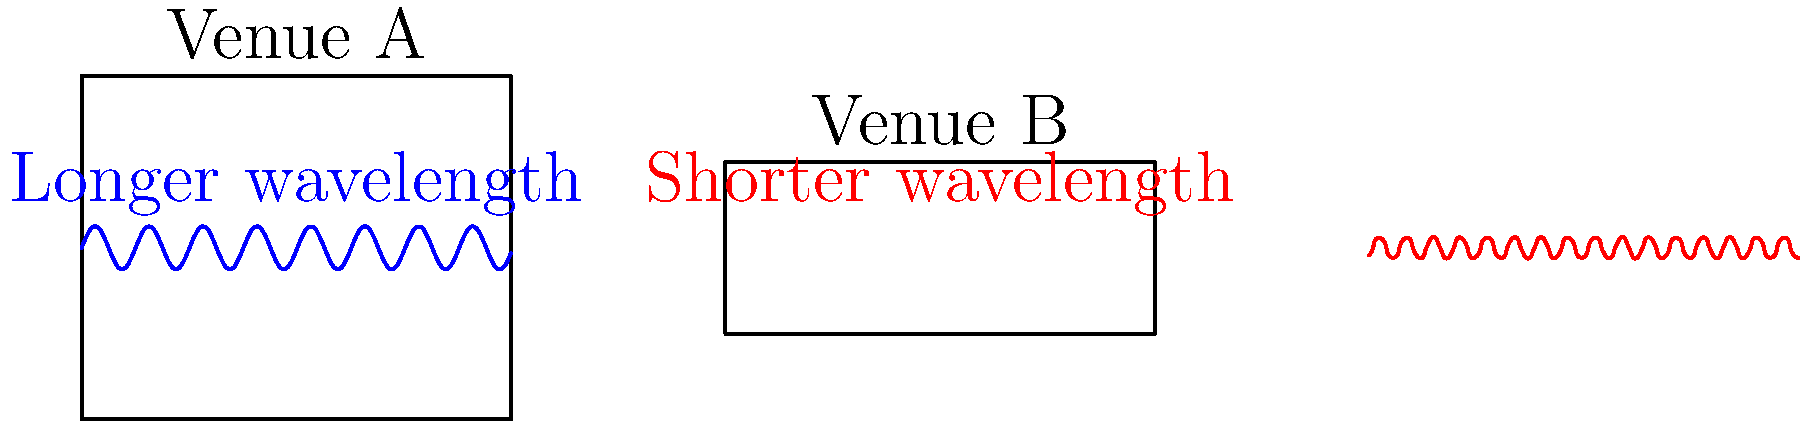Compare the acoustic properties of two local music venues, A and B, as shown in the diagram. Venue A is larger and has longer sound wavelengths, while Venue B is smaller with shorter wavelengths. How does this difference in size and wavelength affect the bass response in each venue, and which venue would likely be better suited for bass-heavy music genres? To answer this question, we need to consider the relationship between venue size, wavelength, and bass response:

1. Wavelength and frequency:
   - Longer wavelengths correspond to lower frequencies (bass)
   - Shorter wavelengths correspond to higher frequencies (treble)

2. Room modes and standing waves:
   - In enclosed spaces, standing waves form at frequencies related to the room dimensions
   - The fundamental room mode frequency is given by: $$f = \frac{c}{2L}$$
     where $c$ is the speed of sound and $L$ is the room length

3. Venue A (larger):
   - Longer wavelengths indicate lower frequencies
   - Lower fundamental room mode frequency due to larger dimensions
   - Better able to support and reproduce low frequencies (bass)

4. Venue B (smaller):
   - Shorter wavelengths indicate higher frequencies
   - Higher fundamental room mode frequency due to smaller dimensions
   - May struggle to accurately reproduce very low frequencies

5. Bass response:
   - Venue A will have a more even and extended bass response
   - Venue B may have more pronounced peaks and dips in the bass region

6. Suitable genres:
   - Venue A would be better suited for bass-heavy genres like electronic dance music, hip-hop, or reggae
   - Venue B might be more appropriate for genres less dependent on deep bass, such as acoustic or classical music

Given these factors, Venue A would likely be better suited for bass-heavy music genres due to its ability to better support and reproduce low frequencies.
Answer: Venue A, due to its larger size and longer wavelengths, allowing better support and reproduction of low frequencies. 